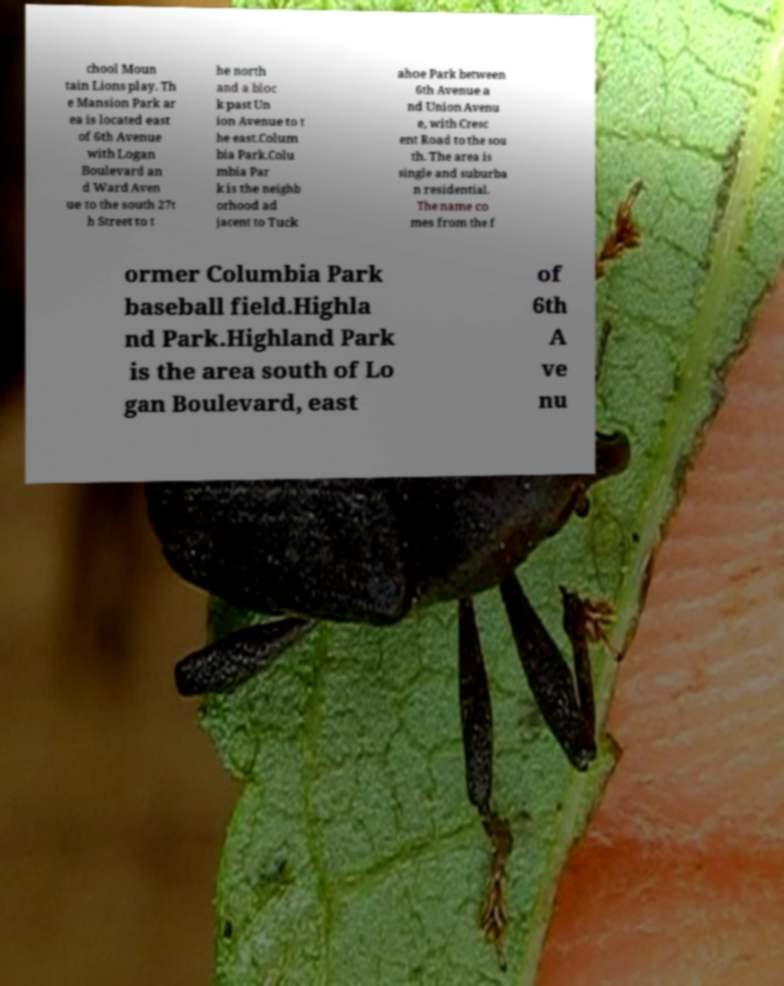There's text embedded in this image that I need extracted. Can you transcribe it verbatim? chool Moun tain Lions play. Th e Mansion Park ar ea is located east of 6th Avenue with Logan Boulevard an d Ward Aven ue to the south 27t h Street to t he north and a bloc k past Un ion Avenue to t he east.Colum bia Park.Colu mbia Par k is the neighb orhood ad jacent to Tuck ahoe Park between 6th Avenue a nd Union Avenu e, with Cresc ent Road to the sou th. The area is single and suburba n residential. The name co mes from the f ormer Columbia Park baseball field.Highla nd Park.Highland Park is the area south of Lo gan Boulevard, east of 6th A ve nu 